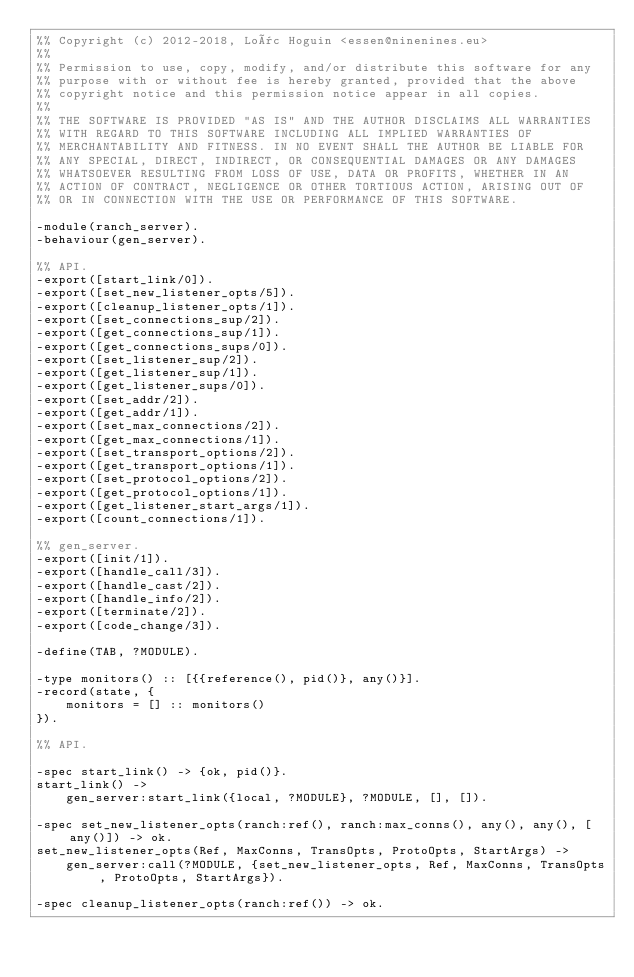<code> <loc_0><loc_0><loc_500><loc_500><_Erlang_>%% Copyright (c) 2012-2018, Loïc Hoguin <essen@ninenines.eu>
%%
%% Permission to use, copy, modify, and/or distribute this software for any
%% purpose with or without fee is hereby granted, provided that the above
%% copyright notice and this permission notice appear in all copies.
%%
%% THE SOFTWARE IS PROVIDED "AS IS" AND THE AUTHOR DISCLAIMS ALL WARRANTIES
%% WITH REGARD TO THIS SOFTWARE INCLUDING ALL IMPLIED WARRANTIES OF
%% MERCHANTABILITY AND FITNESS. IN NO EVENT SHALL THE AUTHOR BE LIABLE FOR
%% ANY SPECIAL, DIRECT, INDIRECT, OR CONSEQUENTIAL DAMAGES OR ANY DAMAGES
%% WHATSOEVER RESULTING FROM LOSS OF USE, DATA OR PROFITS, WHETHER IN AN
%% ACTION OF CONTRACT, NEGLIGENCE OR OTHER TORTIOUS ACTION, ARISING OUT OF
%% OR IN CONNECTION WITH THE USE OR PERFORMANCE OF THIS SOFTWARE.

-module(ranch_server).
-behaviour(gen_server).

%% API.
-export([start_link/0]).
-export([set_new_listener_opts/5]).
-export([cleanup_listener_opts/1]).
-export([set_connections_sup/2]).
-export([get_connections_sup/1]).
-export([get_connections_sups/0]).
-export([set_listener_sup/2]).
-export([get_listener_sup/1]).
-export([get_listener_sups/0]).
-export([set_addr/2]).
-export([get_addr/1]).
-export([set_max_connections/2]).
-export([get_max_connections/1]).
-export([set_transport_options/2]).
-export([get_transport_options/1]).
-export([set_protocol_options/2]).
-export([get_protocol_options/1]).
-export([get_listener_start_args/1]).
-export([count_connections/1]).

%% gen_server.
-export([init/1]).
-export([handle_call/3]).
-export([handle_cast/2]).
-export([handle_info/2]).
-export([terminate/2]).
-export([code_change/3]).

-define(TAB, ?MODULE).

-type monitors() :: [{{reference(), pid()}, any()}].
-record(state, {
	monitors = [] :: monitors()
}).

%% API.

-spec start_link() -> {ok, pid()}.
start_link() ->
	gen_server:start_link({local, ?MODULE}, ?MODULE, [], []).

-spec set_new_listener_opts(ranch:ref(), ranch:max_conns(), any(), any(), [any()]) -> ok.
set_new_listener_opts(Ref, MaxConns, TransOpts, ProtoOpts, StartArgs) ->
	gen_server:call(?MODULE, {set_new_listener_opts, Ref, MaxConns, TransOpts, ProtoOpts, StartArgs}).

-spec cleanup_listener_opts(ranch:ref()) -> ok.</code> 